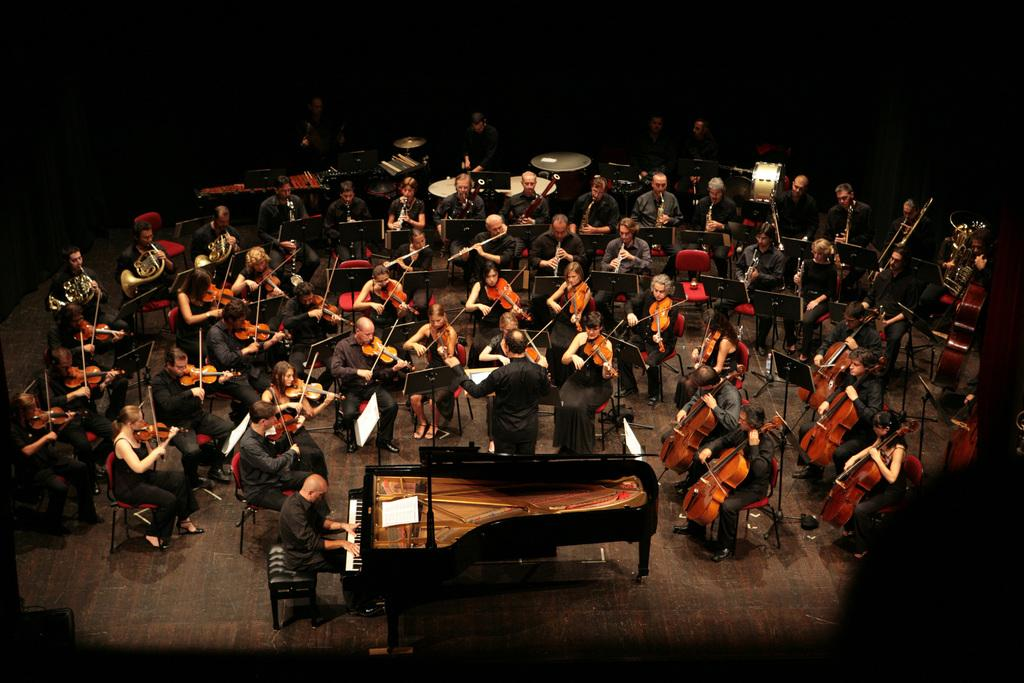What are the people in the image doing? The people in the image are playing musical instruments. Which instruments can be seen being played in the image? The violin, flute, trumpet, and piano are being played in the image. How many different instruments are being played in the image? There are four different instruments being played in the image: the violin, flute, trumpet, and piano. What type of key is used to unlock the poison cabinet in the image? There is no key or poison cabinet present in the image. 